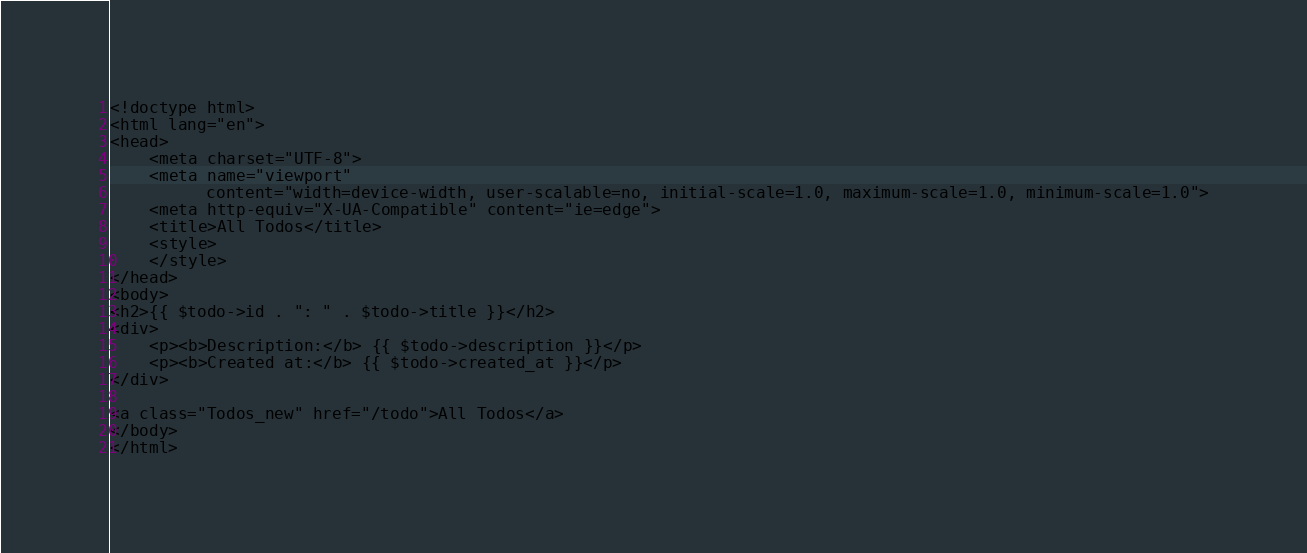Convert code to text. <code><loc_0><loc_0><loc_500><loc_500><_PHP_><!doctype html>
<html lang="en">
<head>
    <meta charset="UTF-8">
    <meta name="viewport"
          content="width=device-width, user-scalable=no, initial-scale=1.0, maximum-scale=1.0, minimum-scale=1.0">
    <meta http-equiv="X-UA-Compatible" content="ie=edge">
    <title>All Todos</title>
    <style>
    </style>
</head>
<body>
<h2>{{ $todo->id . ": " . $todo->title }}</h2>
<div>
    <p><b>Description:</b> {{ $todo->description }}</p>
    <p><b>Created at:</b> {{ $todo->created_at }}</p>
</div>

<a class="Todos_new" href="/todo">All Todos</a>
</body>
</html>
</code> 